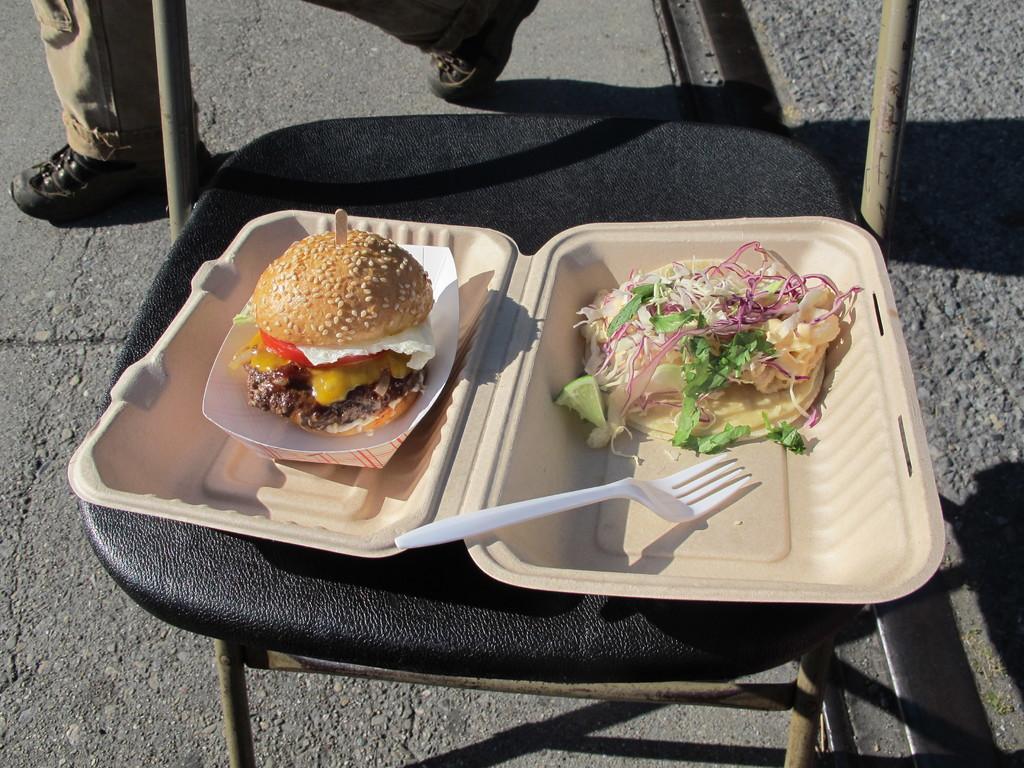In one or two sentences, can you explain what this image depicts? In a given image we can see a chair on a chair a box is placed. This is a salad and a burger with fork. This is a person's leg and shoes. 